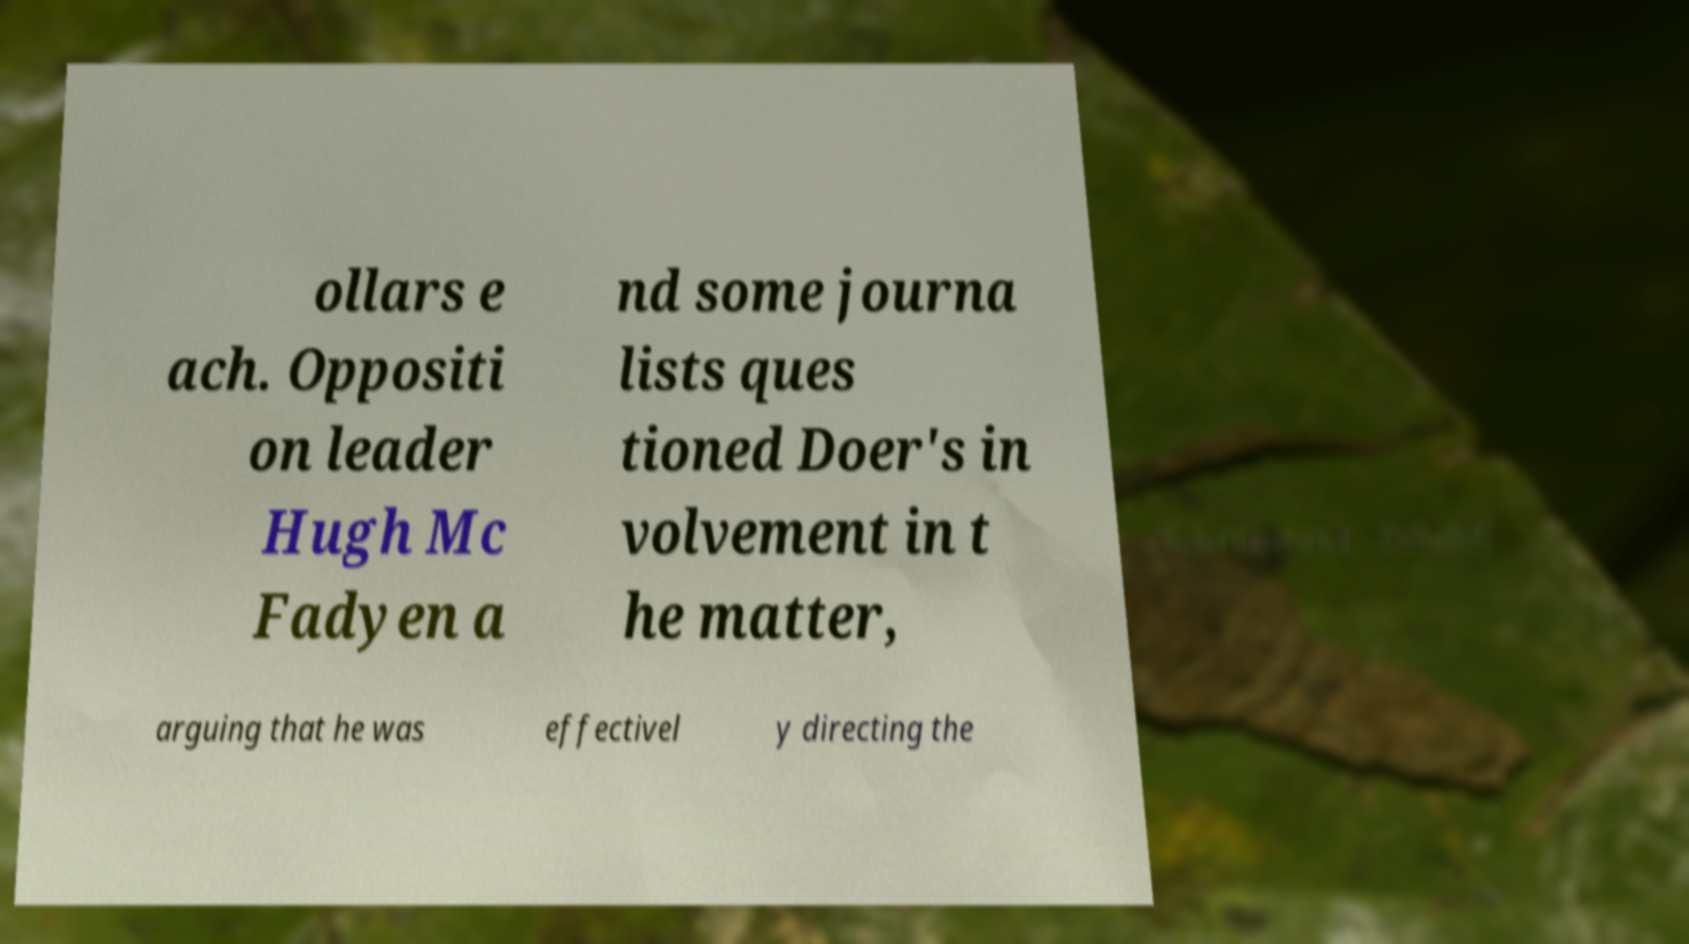Could you extract and type out the text from this image? ollars e ach. Oppositi on leader Hugh Mc Fadyen a nd some journa lists ques tioned Doer's in volvement in t he matter, arguing that he was effectivel y directing the 